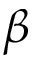Convert formula to latex. <formula><loc_0><loc_0><loc_500><loc_500>\beta</formula> 